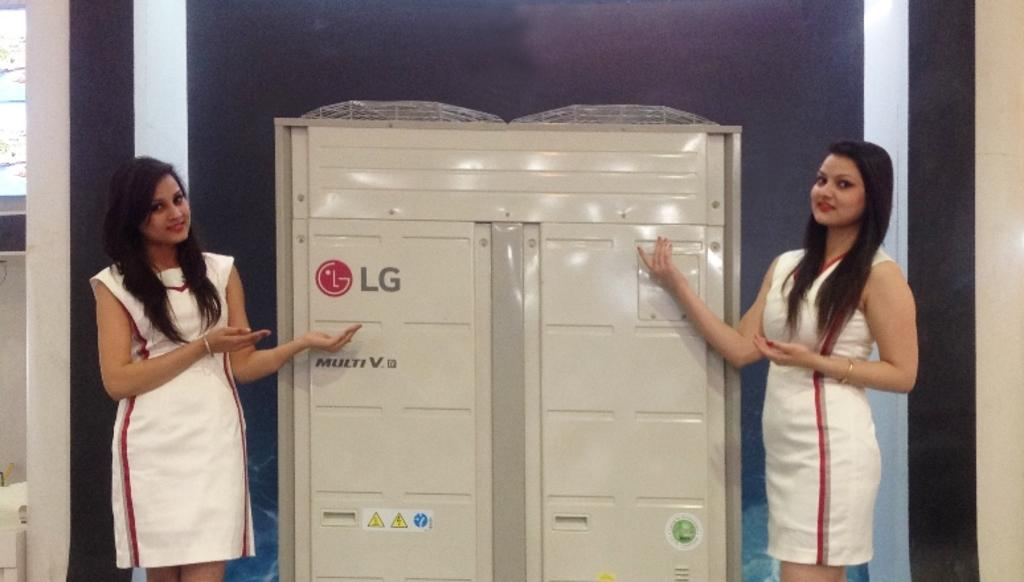How many people are present in the image? There are two women standing in the image. What is the LG object in the image? The details about the LG object are not provided, so we cannot determine its specific type or purpose. What can be seen in the background of the image? There is a wall in the background of the image. Are the women driving a car in the image? There is no car or driving activity depicted in the image. Is there a sofa in the image? There is no mention of a sofa in the provided facts, so we cannot confirm its presence in the image. 